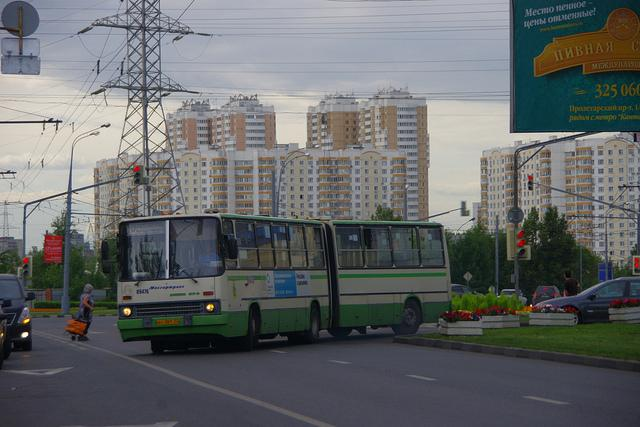What is the woman trying to do?

Choices:
A) cross street
B) board bus
C) board car
D) jog cross street 